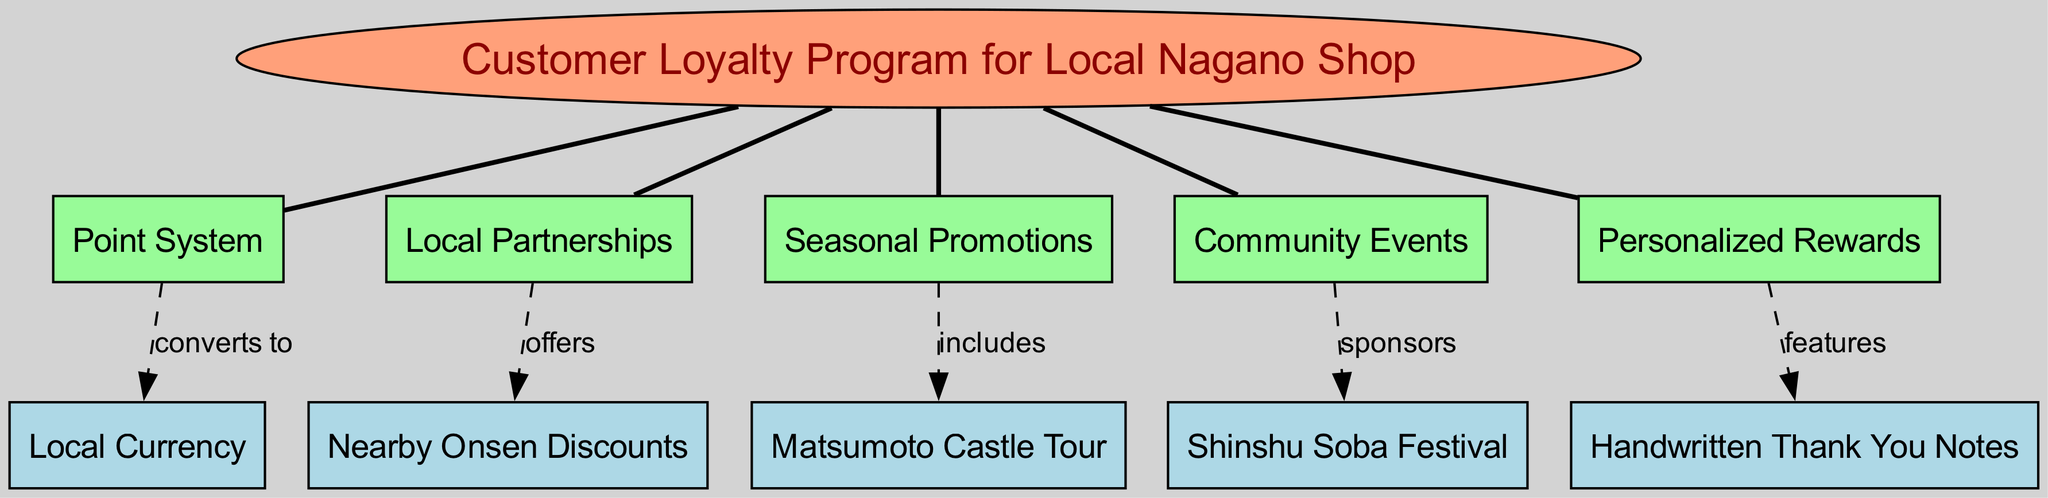What is the central concept of the diagram? The central concept is labeled at the top of the diagram as "Customer Loyalty Program for Local Nagano Shop".
Answer: Customer Loyalty Program for Local Nagano Shop How many main nodes are present in the diagram? The diagram shows five main nodes branching out from the central concept, specifically "Point System", "Local Partnerships", "Seasonal Promotions", "Community Events", and "Personalized Rewards".
Answer: 5 What does the Point System convert to? There is a connection labeled "converts to" going from "Point System" to "Local Currency", indicating that the Point System transforms or exchanges points for Local Currency.
Answer: Local Currency What does Local Partnerships offer? The diagram indicates that "Local Partnerships" has a connection labeled "offers" that goes to "Nearby Onsen Discounts", thus conveying that Local Partnerships provide these discounts.
Answer: Nearby Onsen Discounts Which community event is sponsored by the program? The line labeled "sponsors" indicates that "Community Events" is linked to "Shinshu Soba Festival", meaning that the program sponsors this specific community event.
Answer: Shinshu Soba Festival What type of rewards are featured in the Personalized Rewards strategy? The diagram shows a connection labeled "features" from "Personalized Rewards" to "Handwritten Thank You Notes", suggesting this specific type of reward is included in the strategy.
Answer: Handwritten Thank You Notes What seasonal promotion is mentioned in the diagram? The connection labeled "includes" from "Seasonal Promotions" to "Matsumoto Castle Tour" represents that this specific tour is the seasonal promotion featured in the program.
Answer: Matsumoto Castle Tour What is the relationship between the Point System and Local Currency? The relationship is described as "converts to", meaning that the Point System directly changes or exchanges points for Local Currency in the loyalty program.
Answer: converts to How many connections are made from the main nodes to sub-nodes? There are five connections indicated in the diagram, suggesting that each main node has a specific link to a corresponding sub-node.
Answer: 5 Which strategy includes community festivals? The strategy labeled "Community Events" is connected to "Shinshu Soba Festival", indicating that community festivals fall under this strategy.
Answer: Community Events 